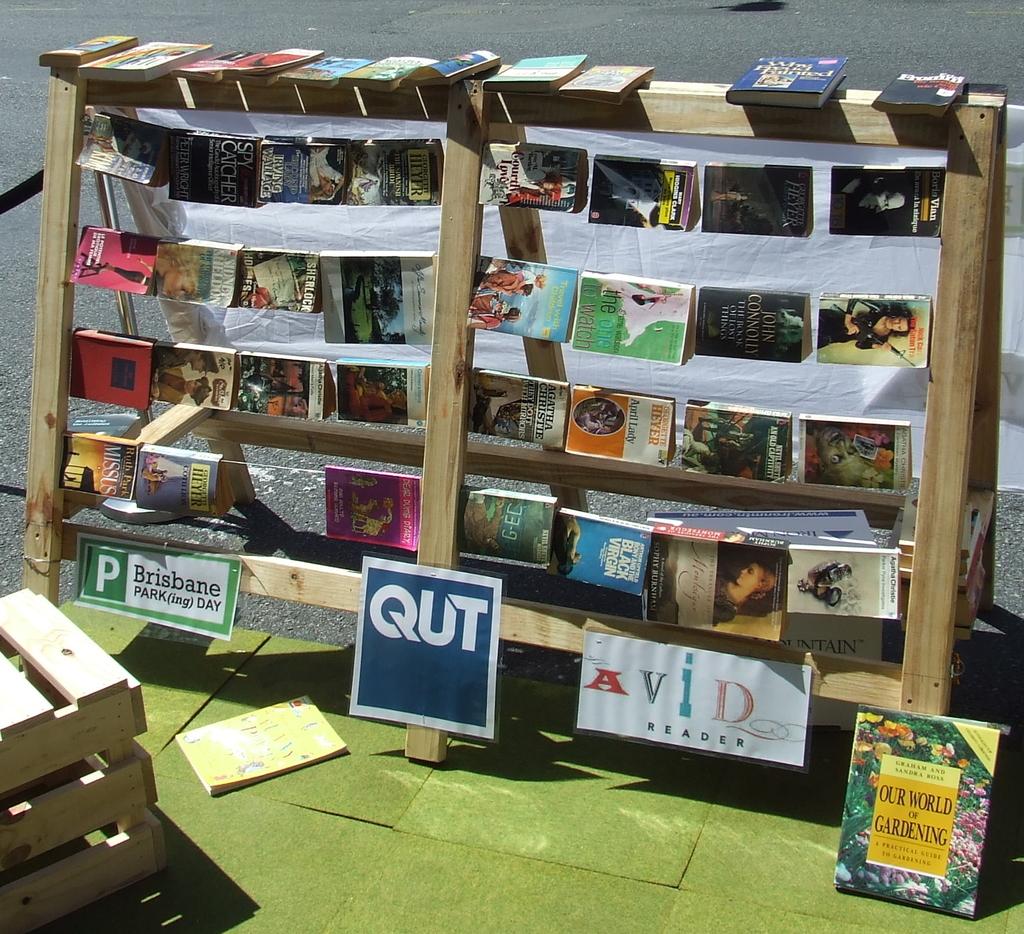What city is the park(ing) day for?
Your response must be concise. Brisbane. What are the three letters on the blue sign in the middle?
Your answer should be compact. Qut. 